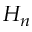Convert formula to latex. <formula><loc_0><loc_0><loc_500><loc_500>H _ { n }</formula> 